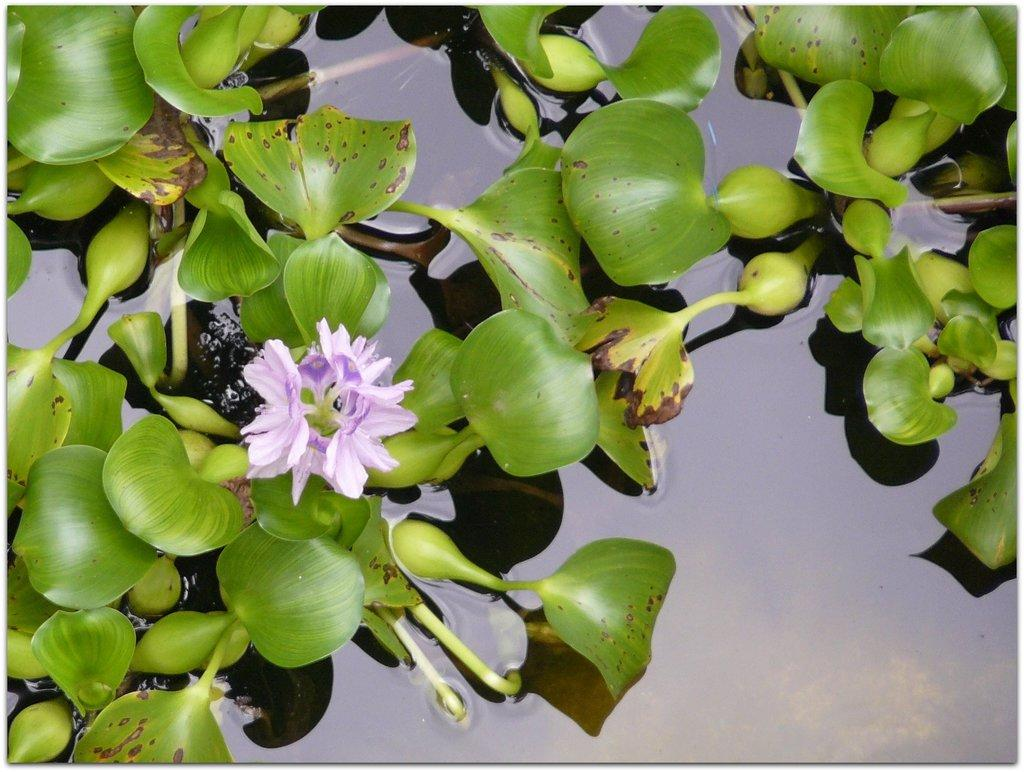What type of plants can be seen in the image? There are flowers and leaves in the image. What is the primary element in which the flowers and leaves are situated? There is water visible in the image, and the flowers and leaves are likely situated in or near the water. What type of spade is being used to dig up the flowers in the image? There is no spade present in the image, and the flowers are not being dug up. 